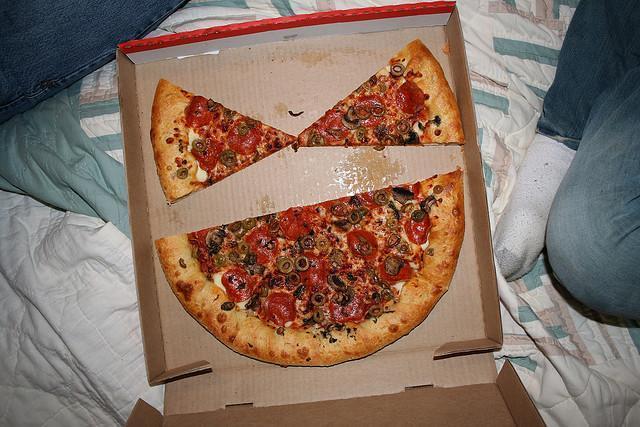How many pizzas can you see?
Give a very brief answer. 3. 